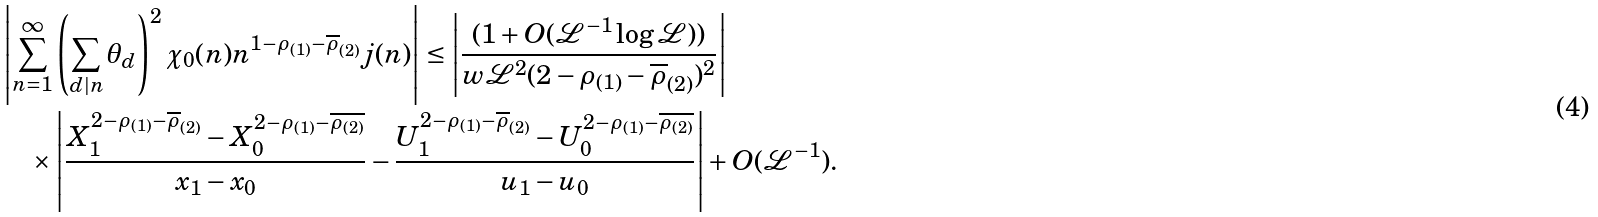<formula> <loc_0><loc_0><loc_500><loc_500>& \left | \sum _ { n = 1 } ^ { \infty } \left ( \sum _ { d | n } \theta _ { d } \right ) ^ { 2 } \chi _ { 0 } ( n ) n ^ { 1 - \rho _ { ( 1 ) } - \overline { \rho } _ { ( 2 ) } } j ( n ) \right | \leq \left | \frac { ( 1 + O ( \mathcal { L } ^ { - 1 } \log { \mathcal { L } } ) ) } { w \mathcal { L } ^ { 2 } ( 2 - \rho _ { ( 1 ) } - \overline { \rho } _ { ( 2 ) } ) ^ { 2 } } \right | \\ & \quad \times \left | \frac { X _ { 1 } ^ { 2 - \rho _ { ( 1 ) } - \overline { \rho } _ { ( 2 ) } } - X _ { 0 } ^ { 2 - \rho _ { ( 1 ) } - \overline { \rho _ { ( 2 ) } } } } { x _ { 1 } - x _ { 0 } } - \frac { U _ { 1 } ^ { 2 - \rho _ { ( 1 ) } - \overline { \rho } _ { ( 2 ) } } - U _ { 0 } ^ { 2 - \rho _ { ( 1 ) } - \overline { \rho _ { ( 2 ) } } } } { u _ { 1 } - u _ { 0 } } \right | + O ( \mathcal { L } ^ { - 1 } ) .</formula> 